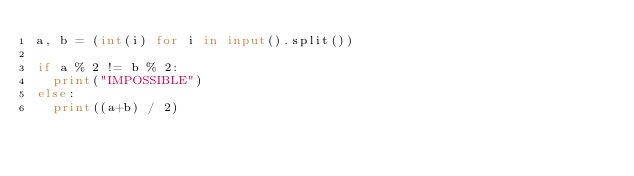<code> <loc_0><loc_0><loc_500><loc_500><_Python_>a, b = (int(i) for i in input().split())

if a % 2 != b % 2:
  print("IMPOSSIBLE")
else:
  print((a+b) / 2)</code> 